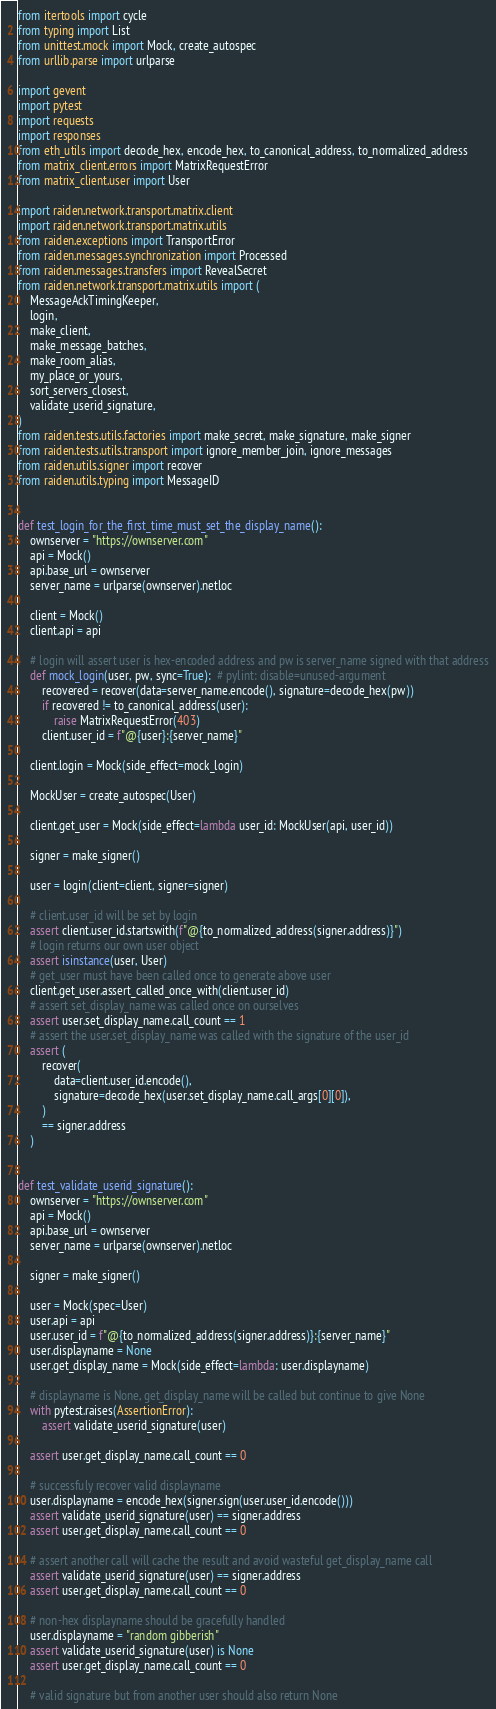Convert code to text. <code><loc_0><loc_0><loc_500><loc_500><_Python_>from itertools import cycle
from typing import List
from unittest.mock import Mock, create_autospec
from urllib.parse import urlparse

import gevent
import pytest
import requests
import responses
from eth_utils import decode_hex, encode_hex, to_canonical_address, to_normalized_address
from matrix_client.errors import MatrixRequestError
from matrix_client.user import User

import raiden.network.transport.matrix.client
import raiden.network.transport.matrix.utils
from raiden.exceptions import TransportError
from raiden.messages.synchronization import Processed
from raiden.messages.transfers import RevealSecret
from raiden.network.transport.matrix.utils import (
    MessageAckTimingKeeper,
    login,
    make_client,
    make_message_batches,
    make_room_alias,
    my_place_or_yours,
    sort_servers_closest,
    validate_userid_signature,
)
from raiden.tests.utils.factories import make_secret, make_signature, make_signer
from raiden.tests.utils.transport import ignore_member_join, ignore_messages
from raiden.utils.signer import recover
from raiden.utils.typing import MessageID


def test_login_for_the_first_time_must_set_the_display_name():
    ownserver = "https://ownserver.com"
    api = Mock()
    api.base_url = ownserver
    server_name = urlparse(ownserver).netloc

    client = Mock()
    client.api = api

    # login will assert user is hex-encoded address and pw is server_name signed with that address
    def mock_login(user, pw, sync=True):  # pylint: disable=unused-argument
        recovered = recover(data=server_name.encode(), signature=decode_hex(pw))
        if recovered != to_canonical_address(user):
            raise MatrixRequestError(403)
        client.user_id = f"@{user}:{server_name}"

    client.login = Mock(side_effect=mock_login)

    MockUser = create_autospec(User)

    client.get_user = Mock(side_effect=lambda user_id: MockUser(api, user_id))

    signer = make_signer()

    user = login(client=client, signer=signer)

    # client.user_id will be set by login
    assert client.user_id.startswith(f"@{to_normalized_address(signer.address)}")
    # login returns our own user object
    assert isinstance(user, User)
    # get_user must have been called once to generate above user
    client.get_user.assert_called_once_with(client.user_id)
    # assert set_display_name was called once on ourselves
    assert user.set_display_name.call_count == 1
    # assert the user.set_display_name was called with the signature of the user_id
    assert (
        recover(
            data=client.user_id.encode(),
            signature=decode_hex(user.set_display_name.call_args[0][0]),
        )
        == signer.address
    )


def test_validate_userid_signature():
    ownserver = "https://ownserver.com"
    api = Mock()
    api.base_url = ownserver
    server_name = urlparse(ownserver).netloc

    signer = make_signer()

    user = Mock(spec=User)
    user.api = api
    user.user_id = f"@{to_normalized_address(signer.address)}:{server_name}"
    user.displayname = None
    user.get_display_name = Mock(side_effect=lambda: user.displayname)

    # displayname is None, get_display_name will be called but continue to give None
    with pytest.raises(AssertionError):
        assert validate_userid_signature(user)

    assert user.get_display_name.call_count == 0

    # successfuly recover valid displayname
    user.displayname = encode_hex(signer.sign(user.user_id.encode()))
    assert validate_userid_signature(user) == signer.address
    assert user.get_display_name.call_count == 0

    # assert another call will cache the result and avoid wasteful get_display_name call
    assert validate_userid_signature(user) == signer.address
    assert user.get_display_name.call_count == 0

    # non-hex displayname should be gracefully handled
    user.displayname = "random gibberish"
    assert validate_userid_signature(user) is None
    assert user.get_display_name.call_count == 0

    # valid signature but from another user should also return None</code> 